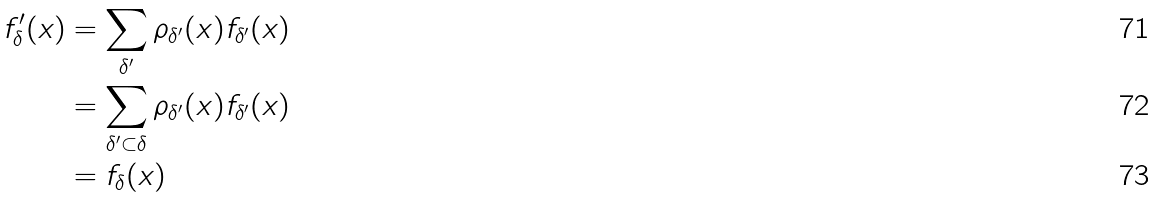<formula> <loc_0><loc_0><loc_500><loc_500>f ^ { \prime } _ { \delta } ( x ) & = \sum _ { \delta ^ { \prime } } \rho _ { \delta ^ { \prime } } ( x ) f _ { \delta ^ { \prime } } ( x ) \\ & = \sum _ { \delta ^ { \prime } \subset \delta } \rho _ { \delta ^ { \prime } } ( x ) f _ { \delta ^ { \prime } } ( x ) \\ & = f _ { \delta } ( x )</formula> 